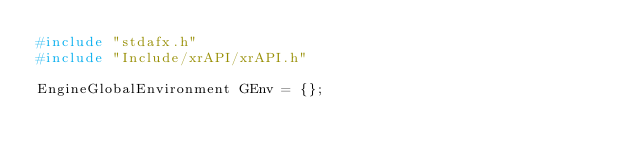Convert code to text. <code><loc_0><loc_0><loc_500><loc_500><_C++_>#include "stdafx.h"
#include "Include/xrAPI/xrAPI.h"

EngineGlobalEnvironment GEnv = {};
</code> 